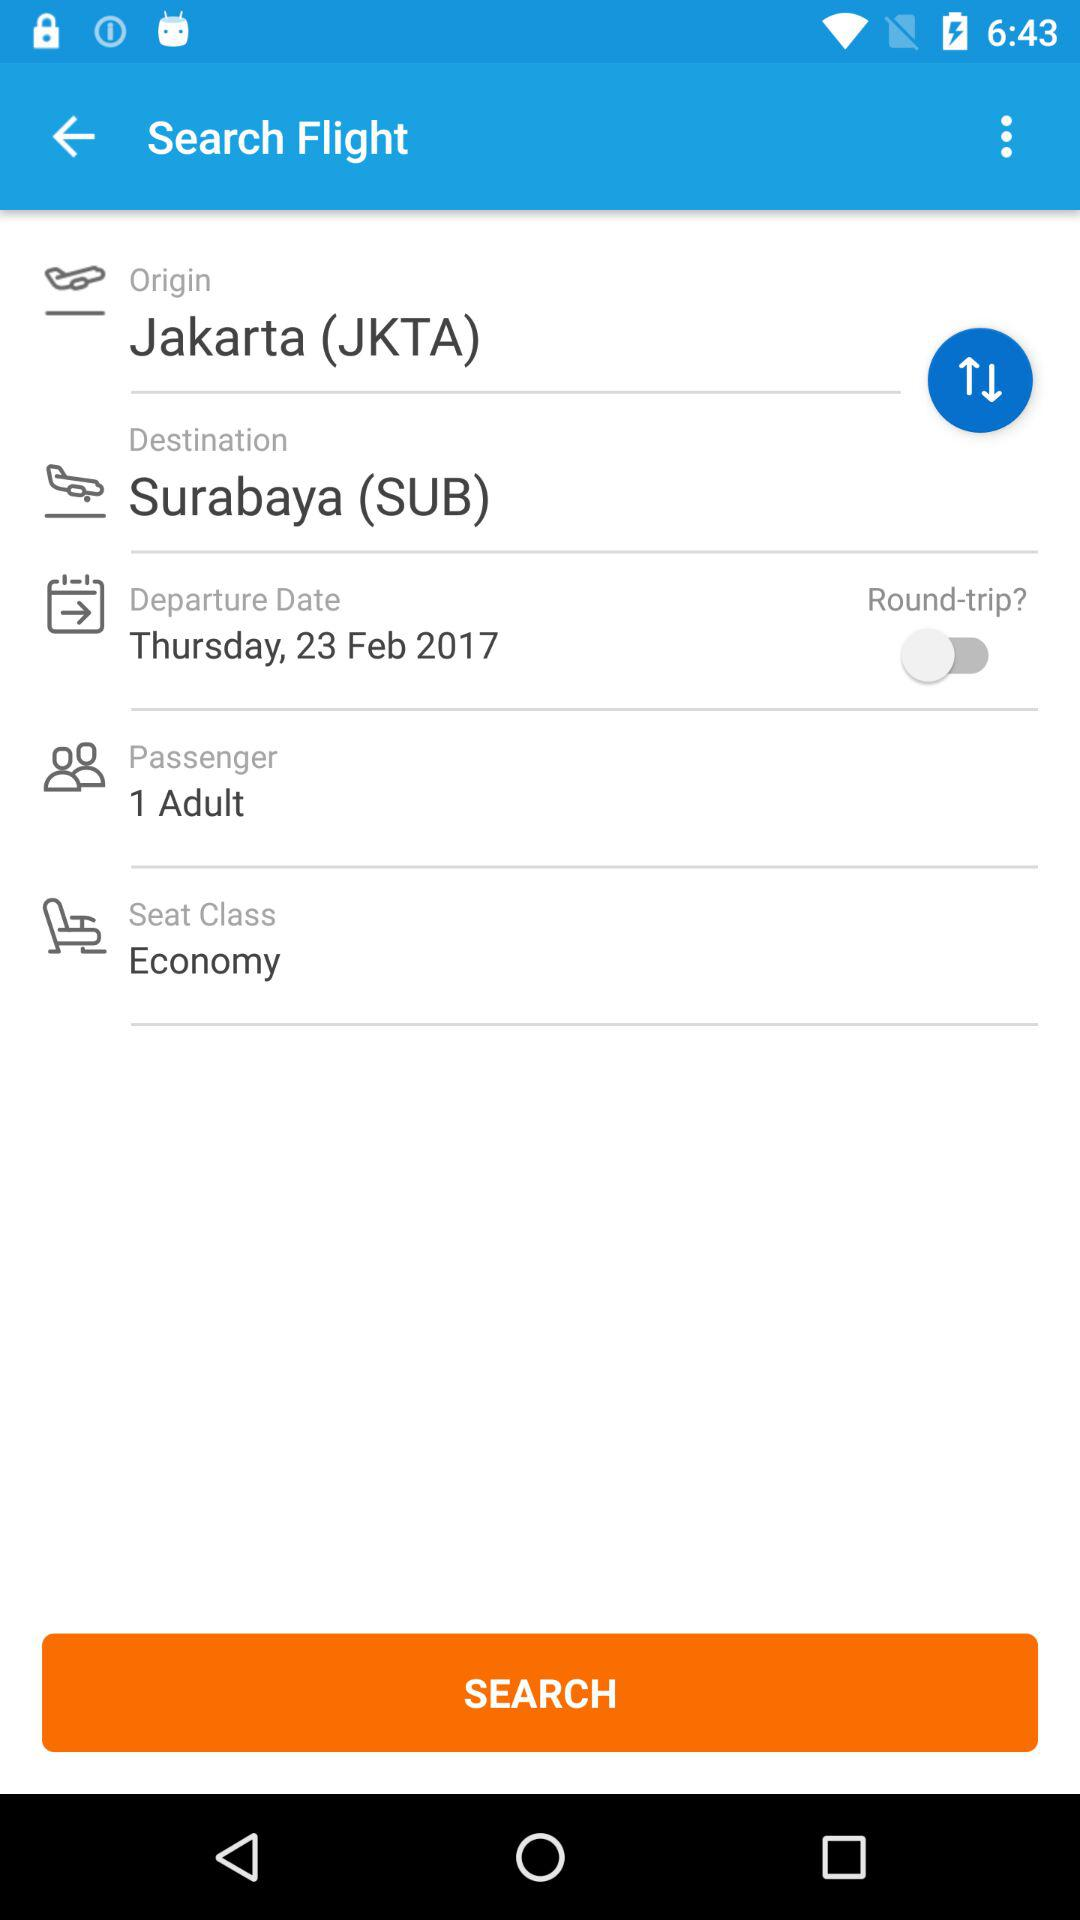What is the origin of the flight? The origin of the flight is Jakarta (JKTA). 